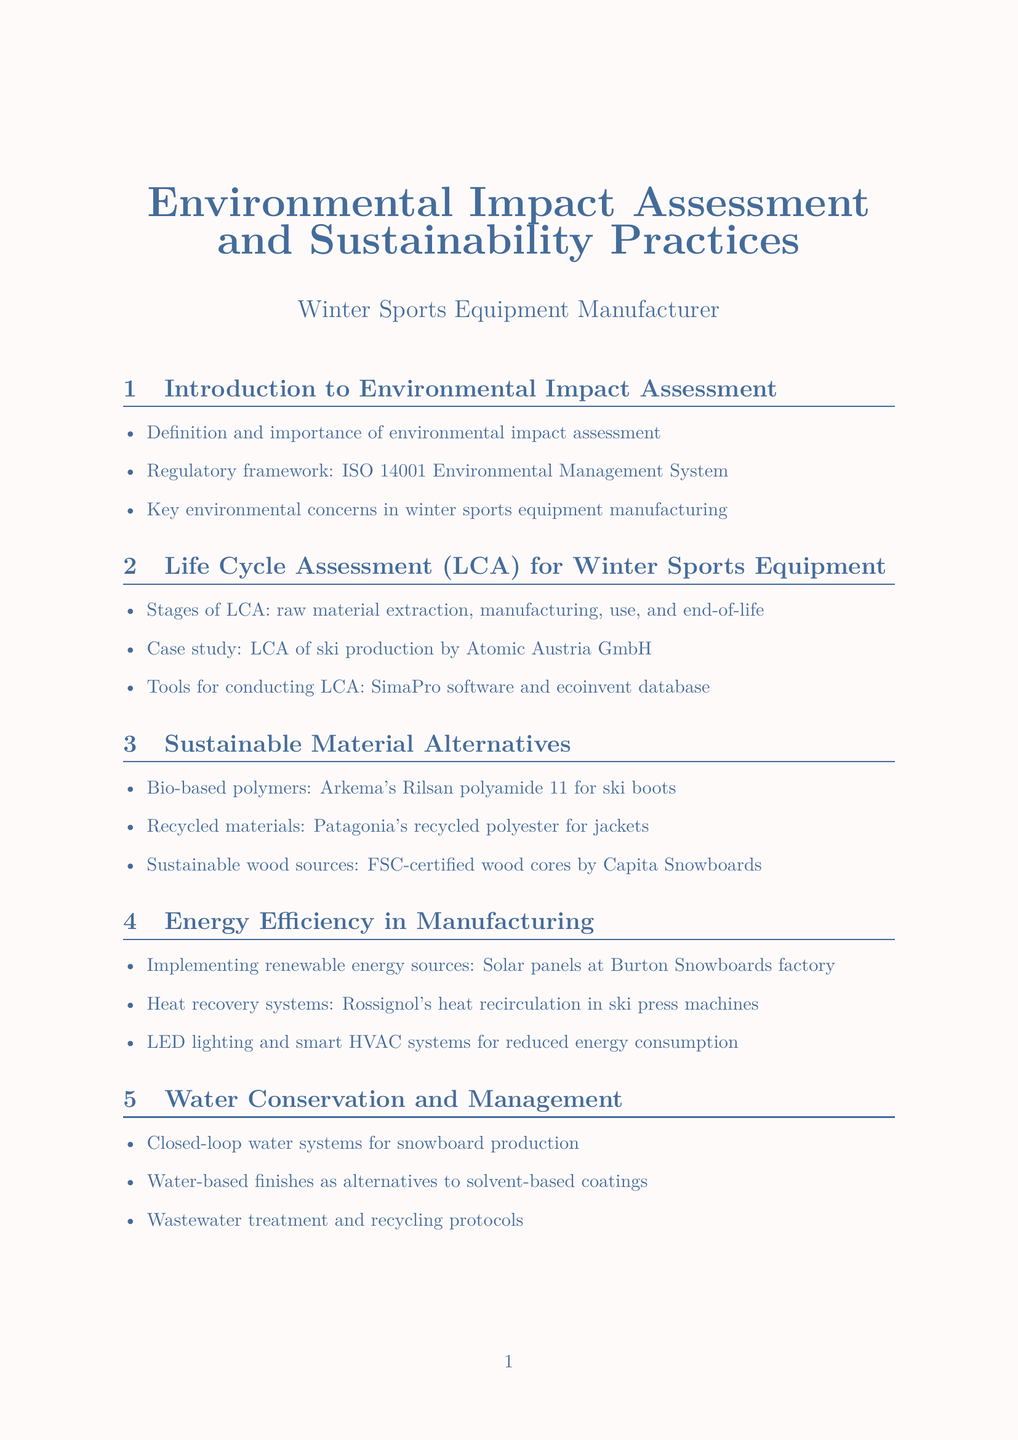What is the ISO standard mentioned in the document? The document references the ISO 14001 Environmental Management System as part of the regulatory framework for environmental impact assessment.
Answer: ISO 14001 What type of material is Arkema's Rilsan polyamide 11? It is categorized as a bio-based polymer used for ski boots, highlighting sustainable material alternatives in production.
Answer: Bio-based polymer Which company has a recycling initiative for used ski boots? Salomon is noted in the document as having a take-back program for this purpose.
Answer: Salomon What technology is suggested for supply chain transparency? The document mentions blockchain technology as a future trend for improving supply chain transparency in winter sports equipment production.
Answer: Blockchain technology What is one of the key environmental concerns in winter sports equipment manufacturing? The document lists key concerns related to environmental impact in the introduction section, such as resource consumption.
Answer: Resource consumption Which company's factory uses solar panels for renewable energy? Burton Snowboards is recognized for implementing solar panels at their factory to enhance energy efficiency.
Answer: Burton Snowboards What is the goal of lean manufacturing principles mentioned in the document? Lean manufacturing principles aim to minimize waste during the production of winter sports equipment, addressing waste reduction protocols.
Answer: Minimize waste What kind of packaging material is discussed in the context of green packaging? The manual refers to biodegradable materials, specifically mycelium-based packaging, as an eco-friendly option for packaging and distribution.
Answer: Biodegradable materials What program does K2 Sports offer related to upcycling? K2 Sports has an initiative for making furniture from old skis, showcasing their commitment to sustainability practices.
Answer: Ski furniture program 